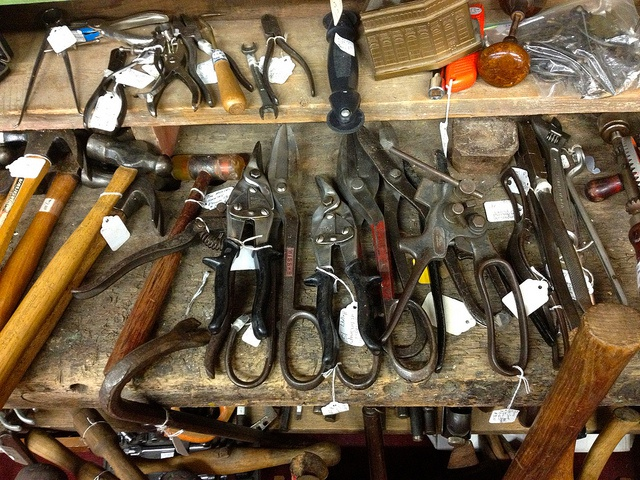Describe the objects in this image and their specific colors. I can see scissors in lightgreen, black, gray, and tan tones, scissors in lightgreen, black, gray, and darkgray tones, scissors in lightgreen, black, gray, and maroon tones, and scissors in lightgreen, black, tan, and gray tones in this image. 